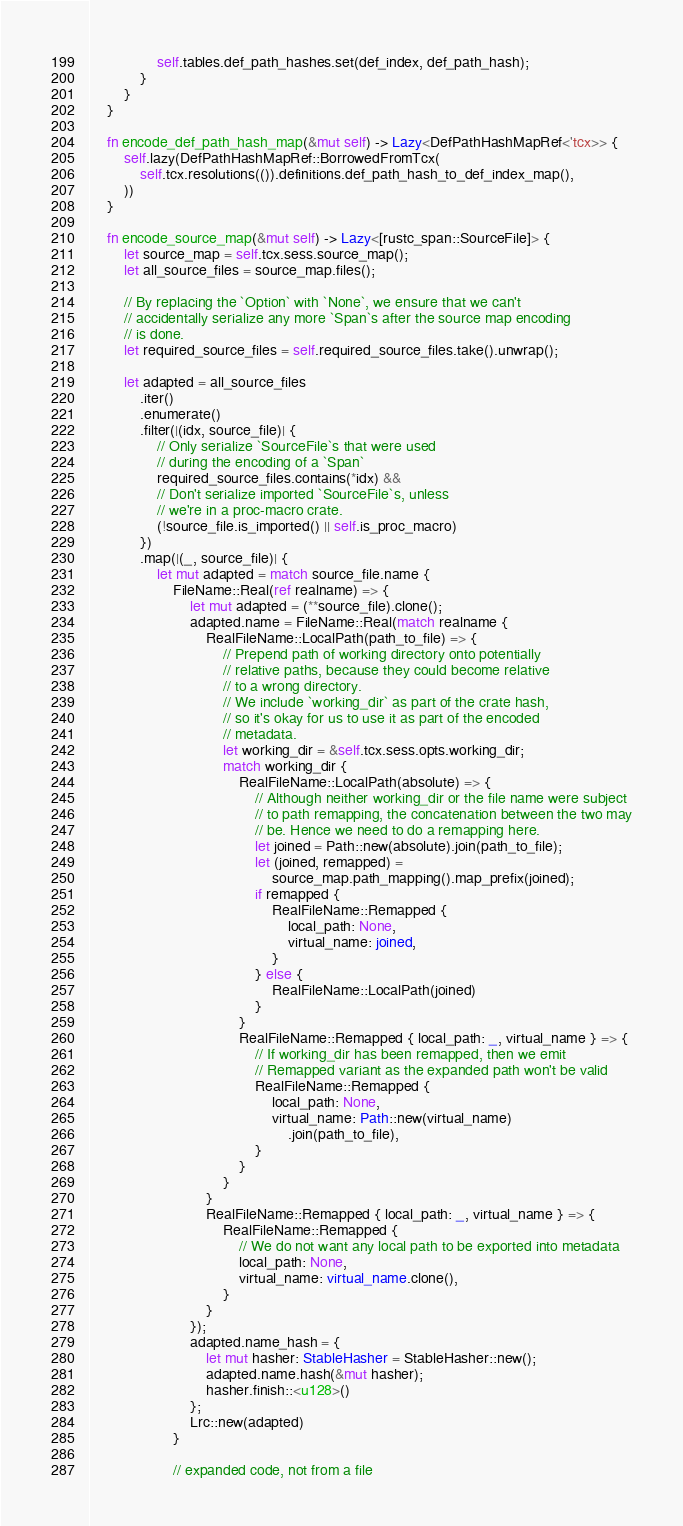Convert code to text. <code><loc_0><loc_0><loc_500><loc_500><_Rust_>                self.tables.def_path_hashes.set(def_index, def_path_hash);
            }
        }
    }

    fn encode_def_path_hash_map(&mut self) -> Lazy<DefPathHashMapRef<'tcx>> {
        self.lazy(DefPathHashMapRef::BorrowedFromTcx(
            self.tcx.resolutions(()).definitions.def_path_hash_to_def_index_map(),
        ))
    }

    fn encode_source_map(&mut self) -> Lazy<[rustc_span::SourceFile]> {
        let source_map = self.tcx.sess.source_map();
        let all_source_files = source_map.files();

        // By replacing the `Option` with `None`, we ensure that we can't
        // accidentally serialize any more `Span`s after the source map encoding
        // is done.
        let required_source_files = self.required_source_files.take().unwrap();

        let adapted = all_source_files
            .iter()
            .enumerate()
            .filter(|(idx, source_file)| {
                // Only serialize `SourceFile`s that were used
                // during the encoding of a `Span`
                required_source_files.contains(*idx) &&
                // Don't serialize imported `SourceFile`s, unless
                // we're in a proc-macro crate.
                (!source_file.is_imported() || self.is_proc_macro)
            })
            .map(|(_, source_file)| {
                let mut adapted = match source_file.name {
                    FileName::Real(ref realname) => {
                        let mut adapted = (**source_file).clone();
                        adapted.name = FileName::Real(match realname {
                            RealFileName::LocalPath(path_to_file) => {
                                // Prepend path of working directory onto potentially
                                // relative paths, because they could become relative
                                // to a wrong directory.
                                // We include `working_dir` as part of the crate hash,
                                // so it's okay for us to use it as part of the encoded
                                // metadata.
                                let working_dir = &self.tcx.sess.opts.working_dir;
                                match working_dir {
                                    RealFileName::LocalPath(absolute) => {
                                        // Although neither working_dir or the file name were subject
                                        // to path remapping, the concatenation between the two may
                                        // be. Hence we need to do a remapping here.
                                        let joined = Path::new(absolute).join(path_to_file);
                                        let (joined, remapped) =
                                            source_map.path_mapping().map_prefix(joined);
                                        if remapped {
                                            RealFileName::Remapped {
                                                local_path: None,
                                                virtual_name: joined,
                                            }
                                        } else {
                                            RealFileName::LocalPath(joined)
                                        }
                                    }
                                    RealFileName::Remapped { local_path: _, virtual_name } => {
                                        // If working_dir has been remapped, then we emit
                                        // Remapped variant as the expanded path won't be valid
                                        RealFileName::Remapped {
                                            local_path: None,
                                            virtual_name: Path::new(virtual_name)
                                                .join(path_to_file),
                                        }
                                    }
                                }
                            }
                            RealFileName::Remapped { local_path: _, virtual_name } => {
                                RealFileName::Remapped {
                                    // We do not want any local path to be exported into metadata
                                    local_path: None,
                                    virtual_name: virtual_name.clone(),
                                }
                            }
                        });
                        adapted.name_hash = {
                            let mut hasher: StableHasher = StableHasher::new();
                            adapted.name.hash(&mut hasher);
                            hasher.finish::<u128>()
                        };
                        Lrc::new(adapted)
                    }

                    // expanded code, not from a file</code> 